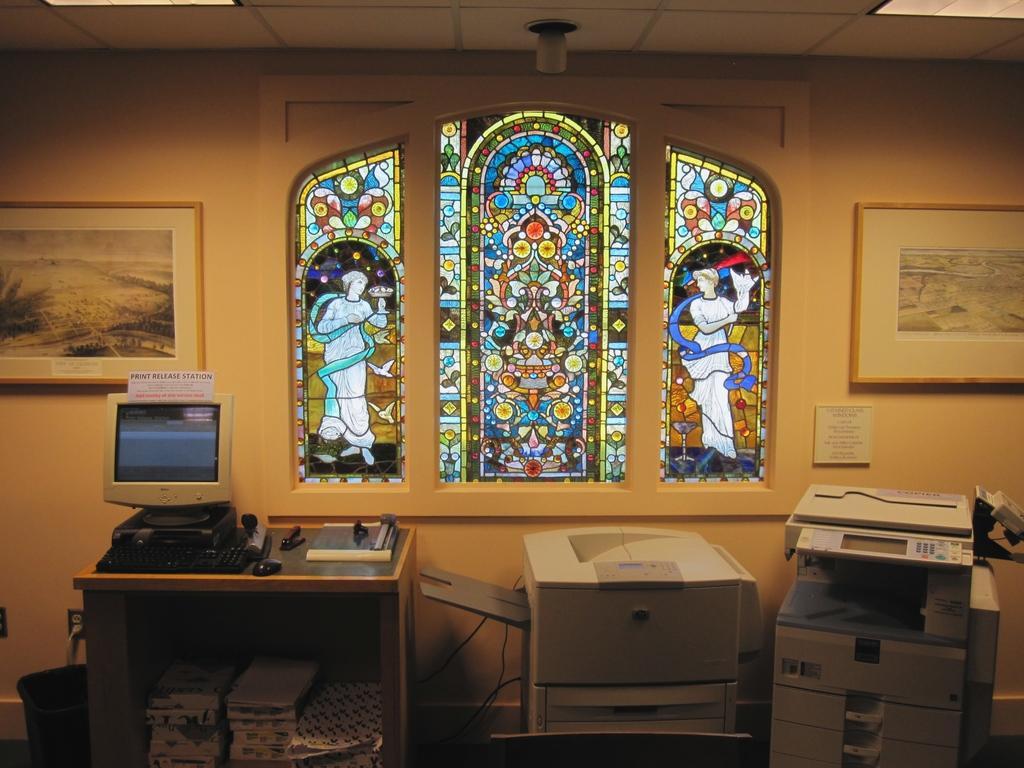Describe this image in one or two sentences. We can able to see a glass painting. Pictures on wall. On this table there is a keyboard, mouse, stapler and monitor. Under the table there are Paper bundles. This is bin. These are xerox machines. 